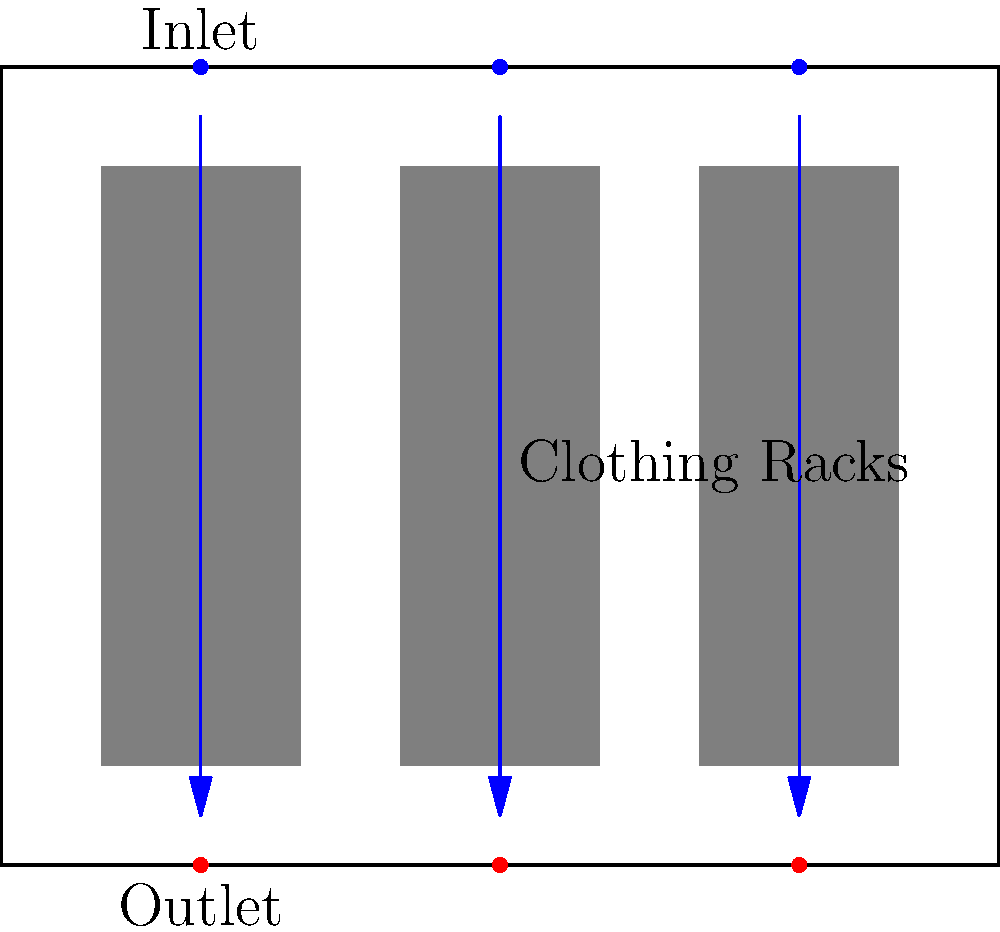In a mindfulness-focused clothing boutique, the layout includes three parallel clothing racks with air inlets at the ceiling and outlets at the floor. If the room dimensions are 10m x 8m x 3m (length x width x height) and the air change rate is 6 ACH (air changes per hour), what is the required volumetric flow rate of air in cubic meters per second (m³/s)? To solve this problem, we'll follow these steps:

1. Calculate the volume of the room:
   Volume = Length x Width x Height
   $$V = 10\text{ m} \times 8\text{ m} \times 3\text{ m} = 240\text{ m}^3$$

2. Convert the air change rate from ACH to changes per second:
   $$6\text{ ACH} = 6 \div 3600\text{ s} = 0.00167\text{ changes/s}$$

3. Calculate the volumetric flow rate:
   Flow rate = Room volume x Air changes per second
   $$Q = 240\text{ m}^3 \times 0.00167\text{ changes/s} = 0.4\text{ m}^3/\text{s}$$

Therefore, the required volumetric flow rate is 0.4 m³/s.
Answer: 0.4 m³/s 